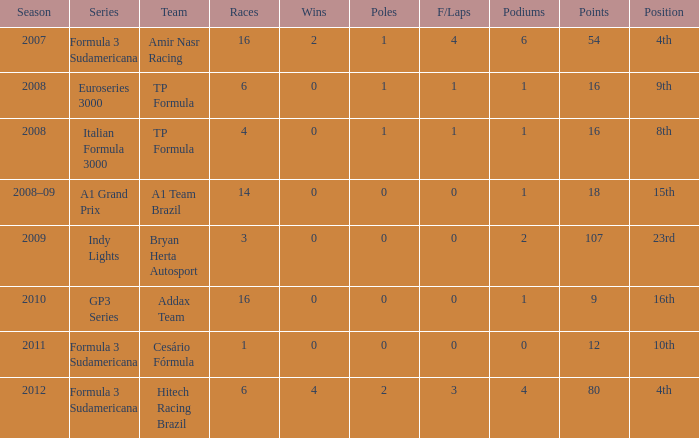0 poles? 80.0. 